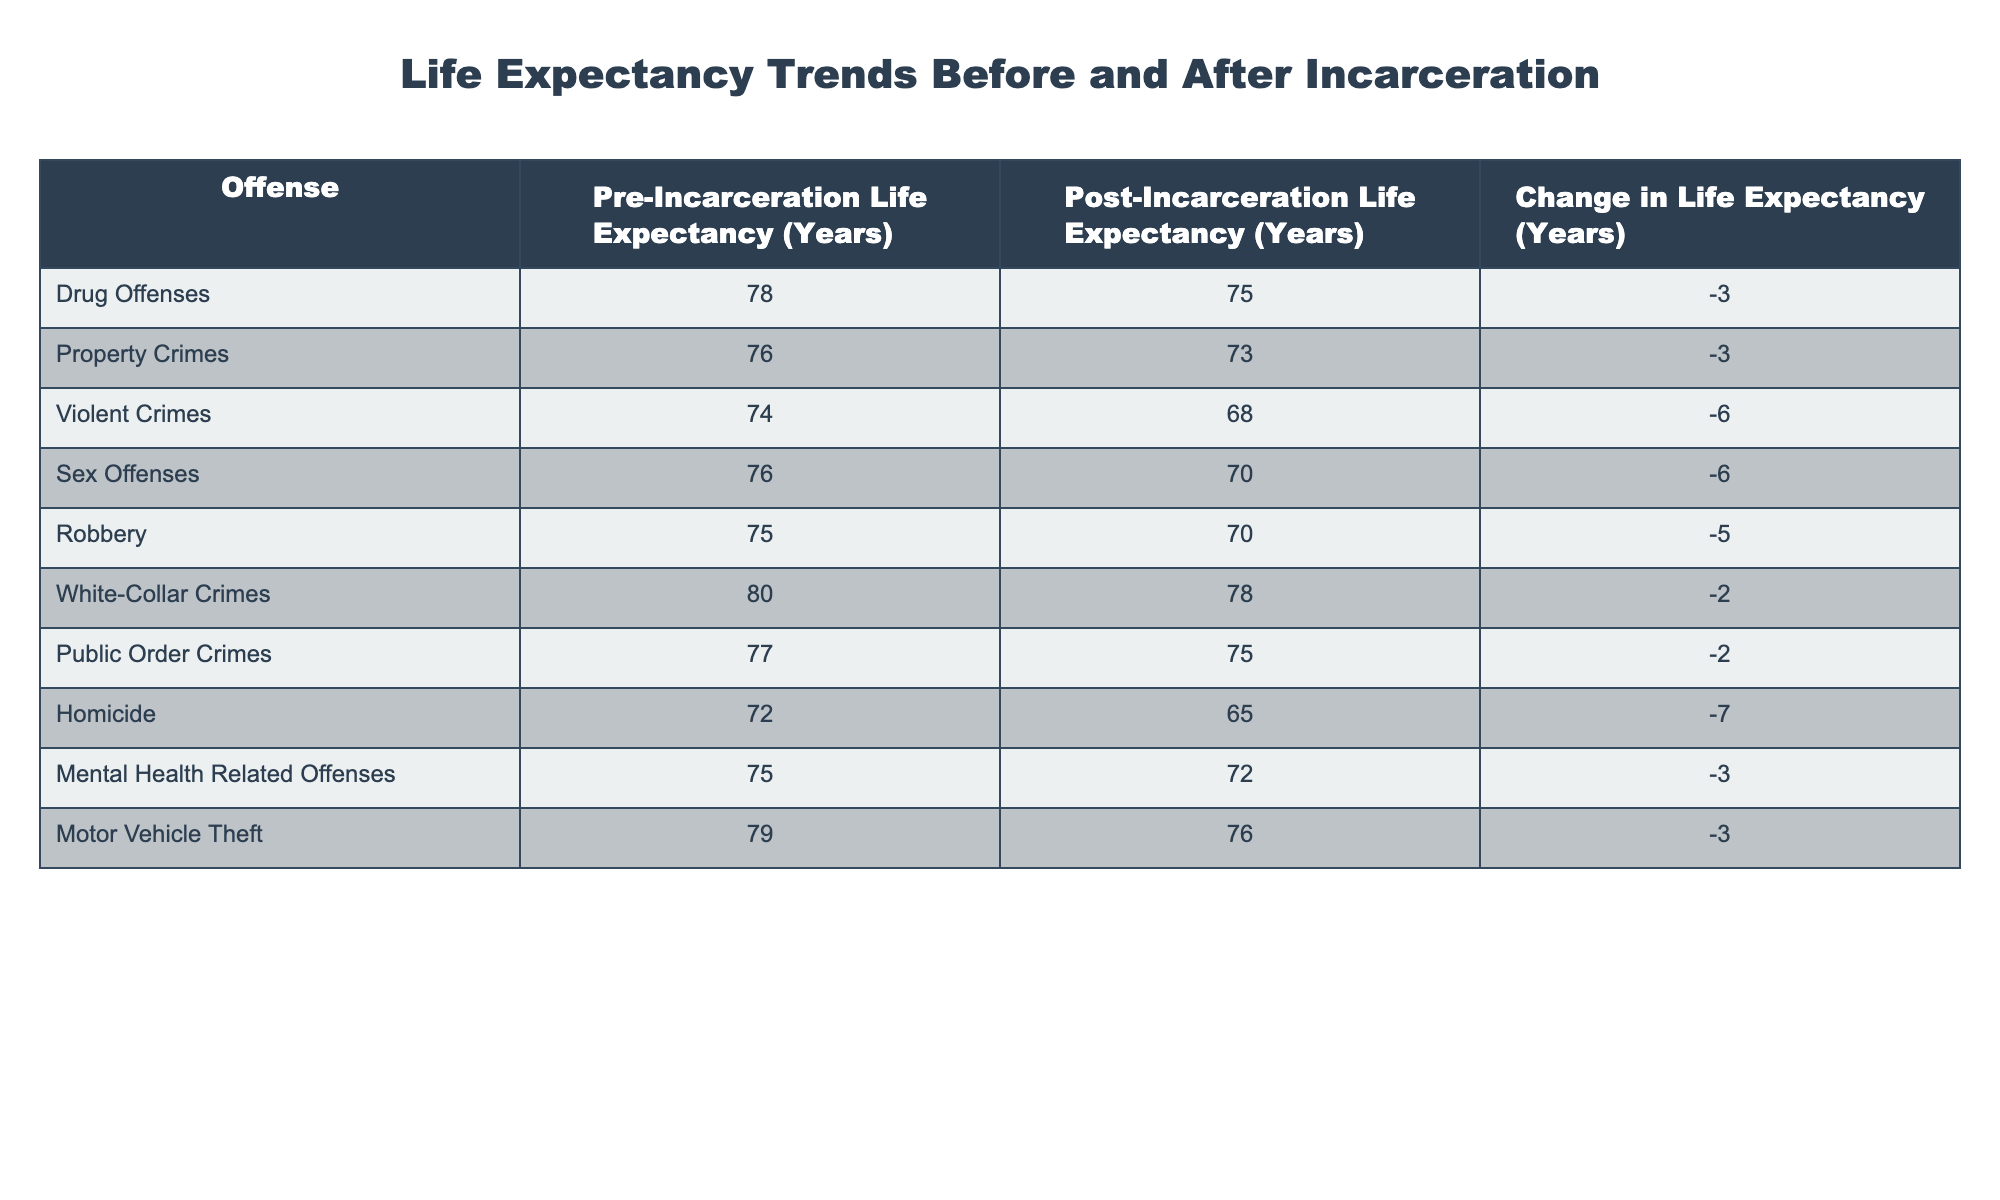What is the pre-incarceration life expectancy for individuals convicted of robbery? According to the table, the pre-incarceration life expectancy for individuals convicted of robbery is listed under the corresponding column, which shows a value of 75 years.
Answer: 75 How much does life expectancy change for individuals incarcerated for violent crimes? The change in life expectancy for individuals incarcerated for violent crimes can be found in the table, which indicates a decrease of 6 years (from 74 years pre-incarceration to 68 years post-incarceration).
Answer: -6 What is the average pre-incarceration life expectancy across all offenses? To find the average pre-incarceration life expectancy, sum all the values in that column (78 + 76 + 74 + 76 + 75 + 80 + 77 + 72 + 75 + 79) =  763, then divide by the number of offenses (10). Thus, the average is 763/10 = 76.3 years.
Answer: 76.3 Is the post-incarceration life expectancy for individuals convicted of white-collar crimes higher than that of those convicted of sex offenses? From the table, the post-incarceration life expectancy for white-collar crimes is 78 years and for sex offenses, it is 70 years. Since 78 is greater than 70, the answer is yes.
Answer: Yes What is the total change in life expectancy for individuals incarcerated due to drug offenses and property crimes combined? The change in life expectancy for drug offenses is -3 years and for property crimes is also -3 years. By adding these two values together (-3 + -3), we find the total change is -6 years for both offenses combined.
Answer: -6 How many offenses have a post-incarceration life expectancy of 75 years or higher? By examining the post-incarceration life expectancy column, we see that the offenses with a life expectancy of 75 years or higher are drug offenses (75), white-collar crimes (78), and public order crimes (75)—a total of three offenses.
Answer: 3 Which offense shows the greatest decline in life expectancy post-incarceration? Looking at the "Change in Life Expectancy" column, the greatest decline is seen in homicide, which shows a decline of 7 years (from 72 to 65).
Answer: Homicide What percentage of the offenses analyzed show a decrease in life expectancy after incarceration? Out of the 10 offenses listed, 9 offenses show a decrease in life expectancy, therefore the percentage is (9/10) * 100 = 90%.
Answer: 90% 